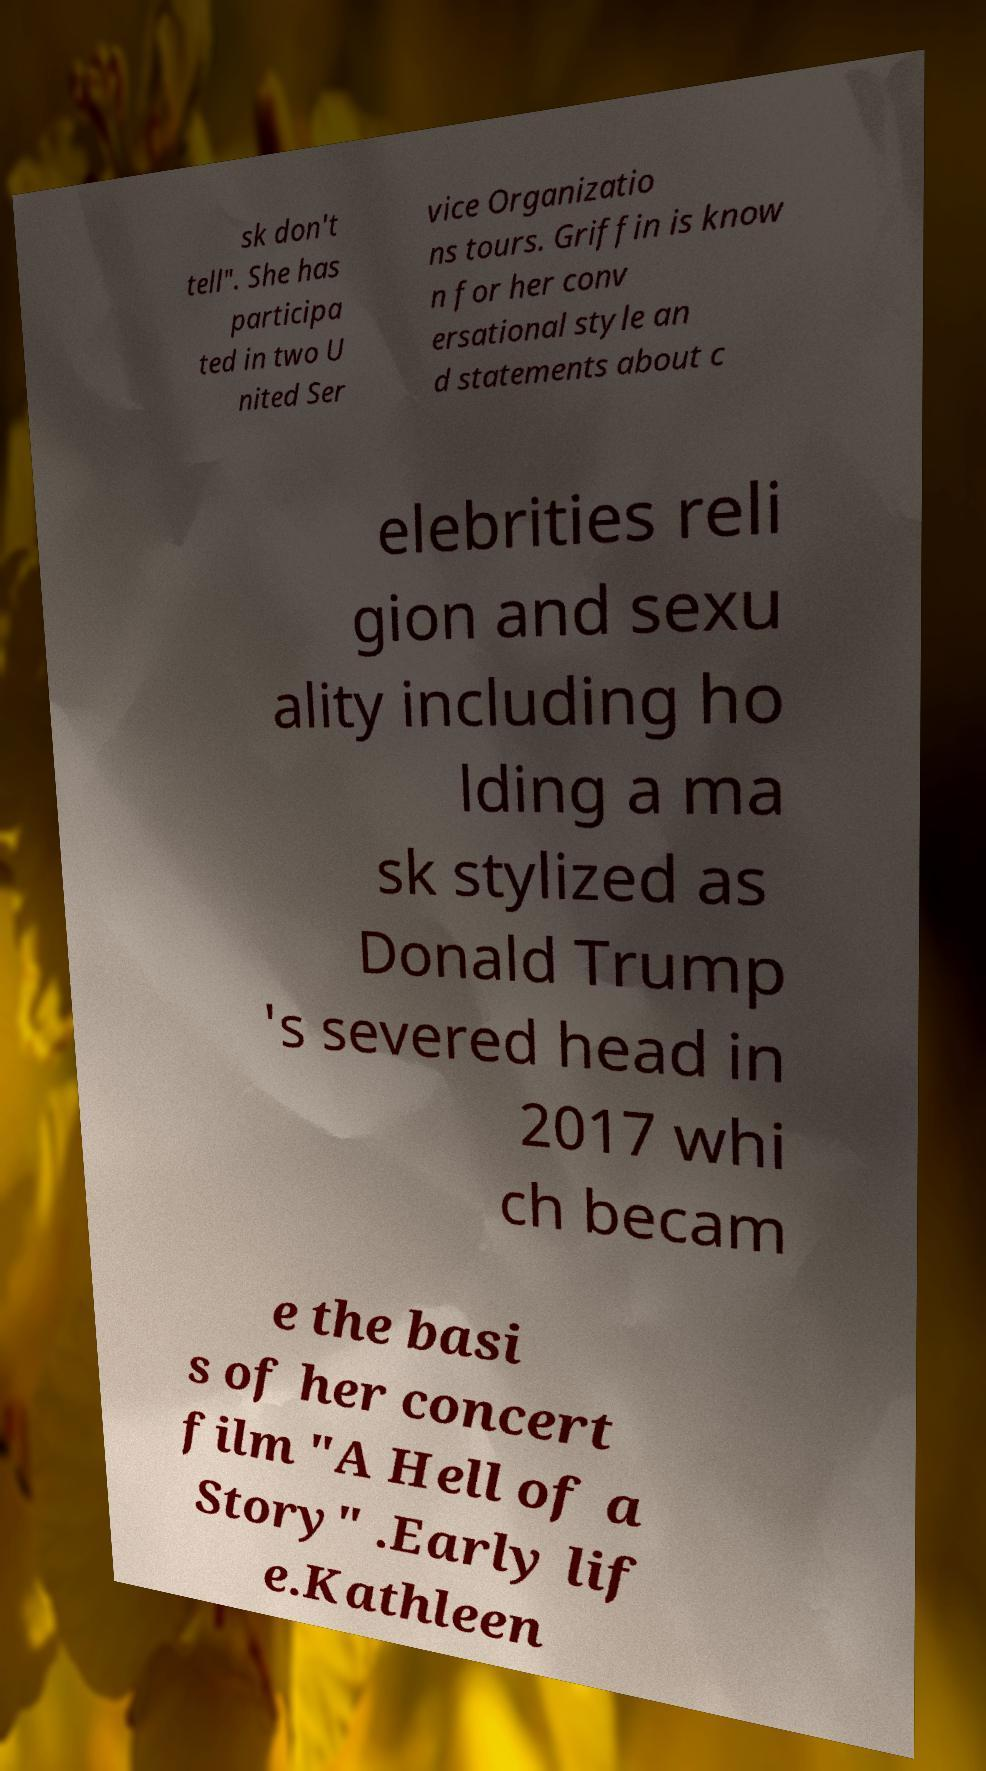What messages or text are displayed in this image? I need them in a readable, typed format. sk don't tell". She has participa ted in two U nited Ser vice Organizatio ns tours. Griffin is know n for her conv ersational style an d statements about c elebrities reli gion and sexu ality including ho lding a ma sk stylized as Donald Trump 's severed head in 2017 whi ch becam e the basi s of her concert film "A Hell of a Story" .Early lif e.Kathleen 